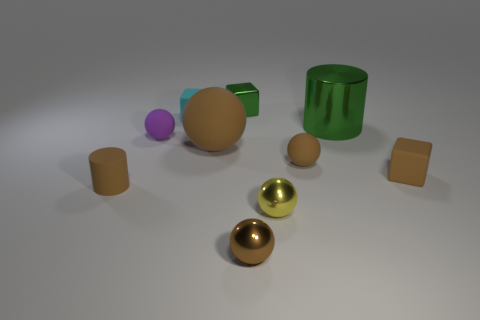Is the color of the cylinder that is in front of the tiny purple rubber ball the same as the big rubber ball?
Offer a very short reply. Yes. Are there more large brown objects than large red metallic spheres?
Offer a terse response. Yes. There is a cylinder right of the cylinder that is left of the big thing that is in front of the large green metal object; what is its material?
Make the answer very short. Metal. Does the big cylinder have the same color as the metallic block?
Your response must be concise. Yes. Are there any other large shiny cylinders that have the same color as the big metallic cylinder?
Your answer should be very brief. No. What is the shape of the brown metallic object that is the same size as the brown matte block?
Offer a very short reply. Sphere. Are there fewer tiny brown matte cylinders than tiny cyan rubber spheres?
Offer a very short reply. No. How many other rubber objects have the same size as the cyan thing?
Offer a terse response. 4. What shape is the small metallic thing that is the same color as the large ball?
Keep it short and to the point. Sphere. What is the material of the tiny green thing?
Provide a short and direct response. Metal. 